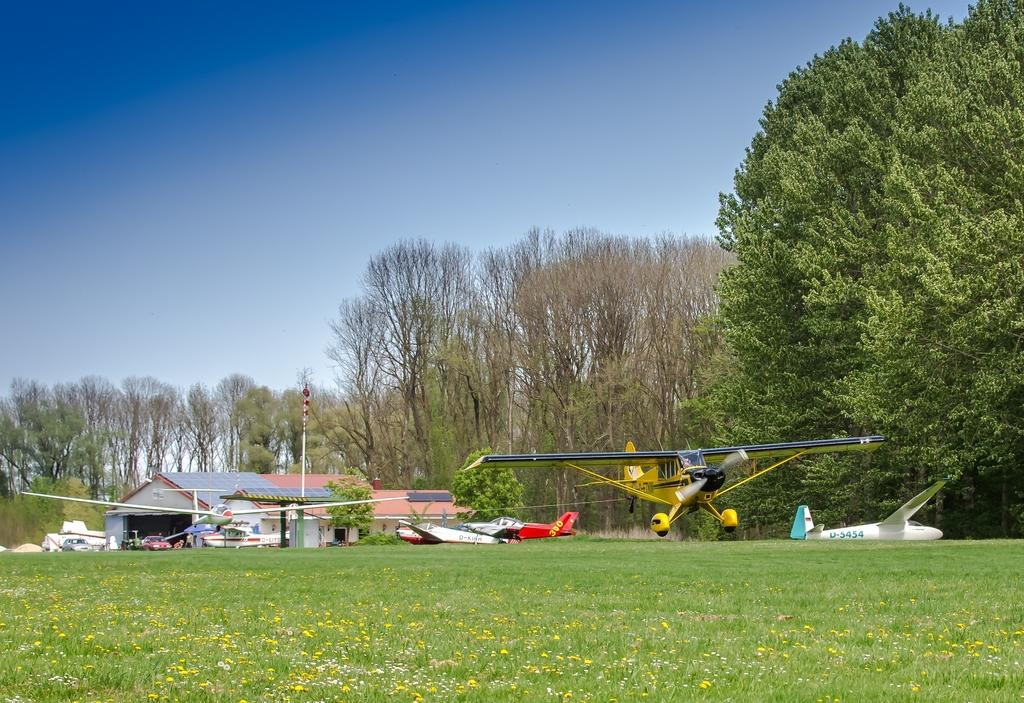What types of living organisms can be seen in the image? Plants and flowers are visible in the image. What man-made structures can be seen in the image? There are sheds and a pole visible in the image. What mode of transportation can be seen in the image? There are vehicles and airplanes visible in the image. What is visible in the background of the image? The sky is visible in the background of the image. What type of vegetation is present in the image? Trees are present in the image. Where is the library located in the image? There is no library present in the image. What type of light can be seen illuminating the garden in the image? There is no garden present in the image, and therefore no specific type of light can be identified. 